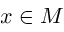<formula> <loc_0><loc_0><loc_500><loc_500>x \in M</formula> 